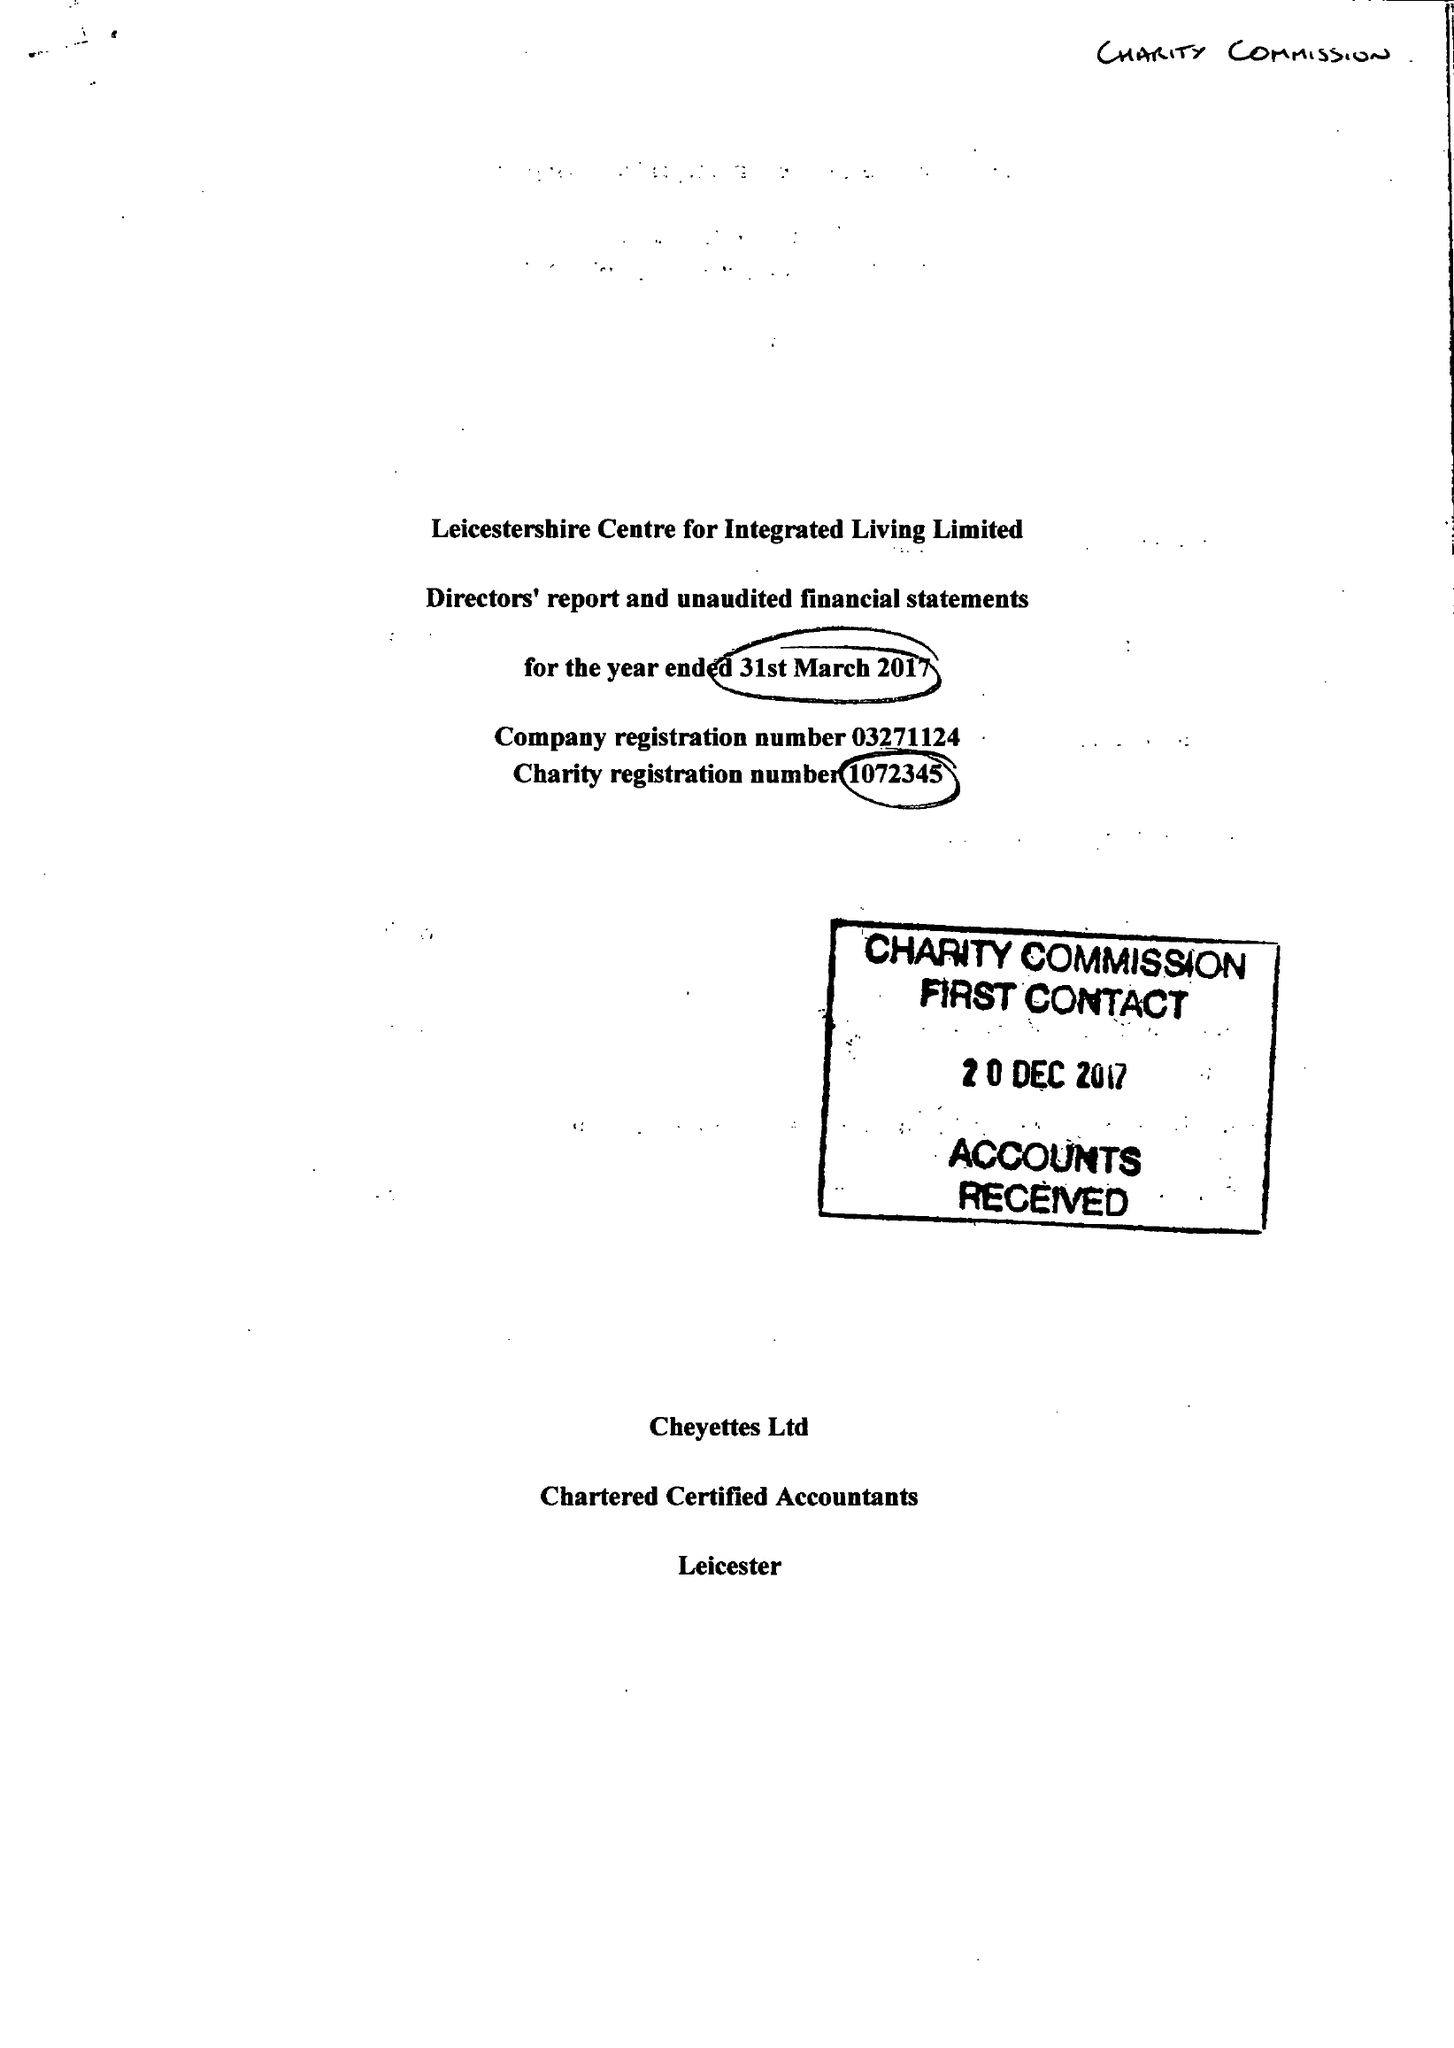What is the value for the charity_name?
Answer the question using a single word or phrase. Leicestershire Centre For Integrated Living Ltd. 